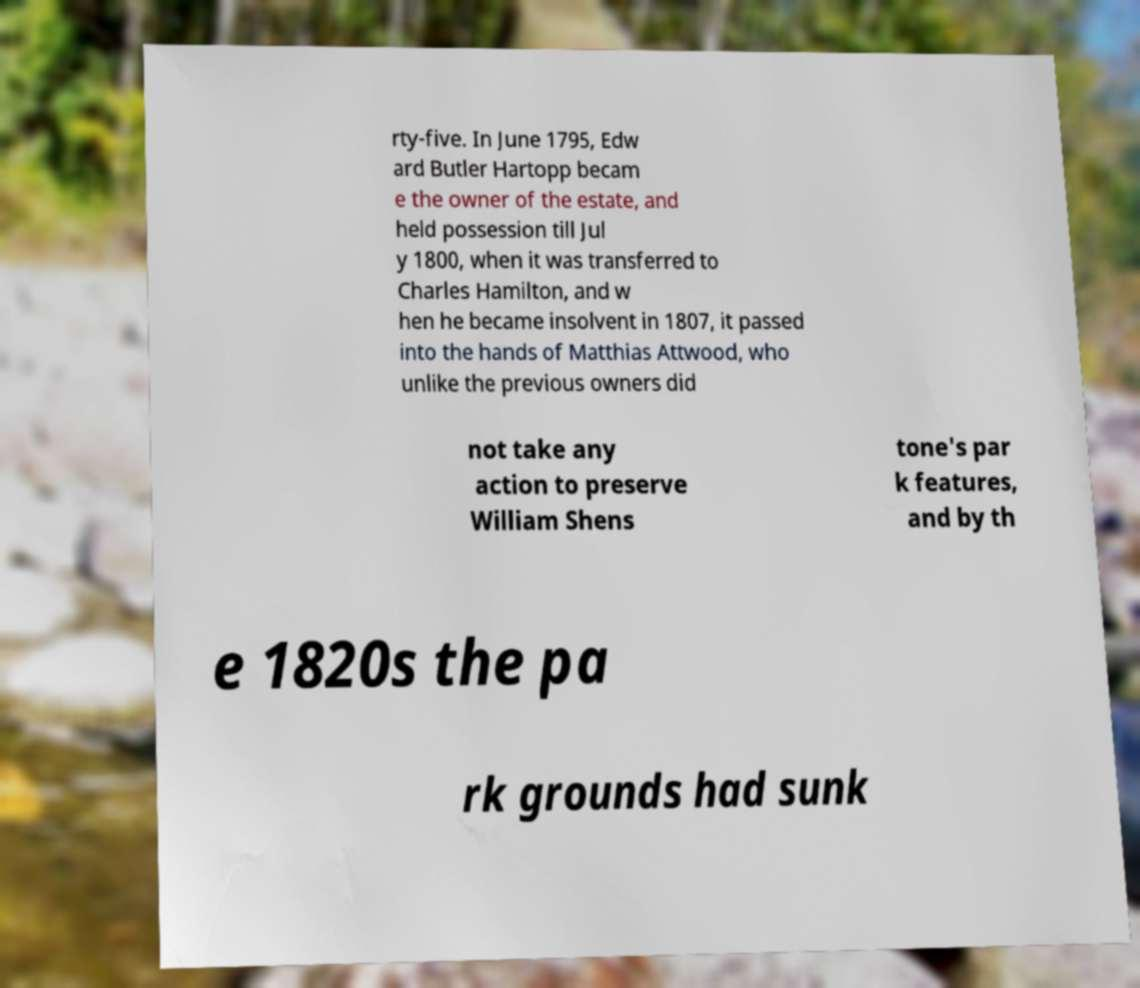There's text embedded in this image that I need extracted. Can you transcribe it verbatim? rty-five. In June 1795, Edw ard Butler Hartopp becam e the owner of the estate, and held possession till Jul y 1800, when it was transferred to Charles Hamilton, and w hen he became insolvent in 1807, it passed into the hands of Matthias Attwood, who unlike the previous owners did not take any action to preserve William Shens tone's par k features, and by th e 1820s the pa rk grounds had sunk 